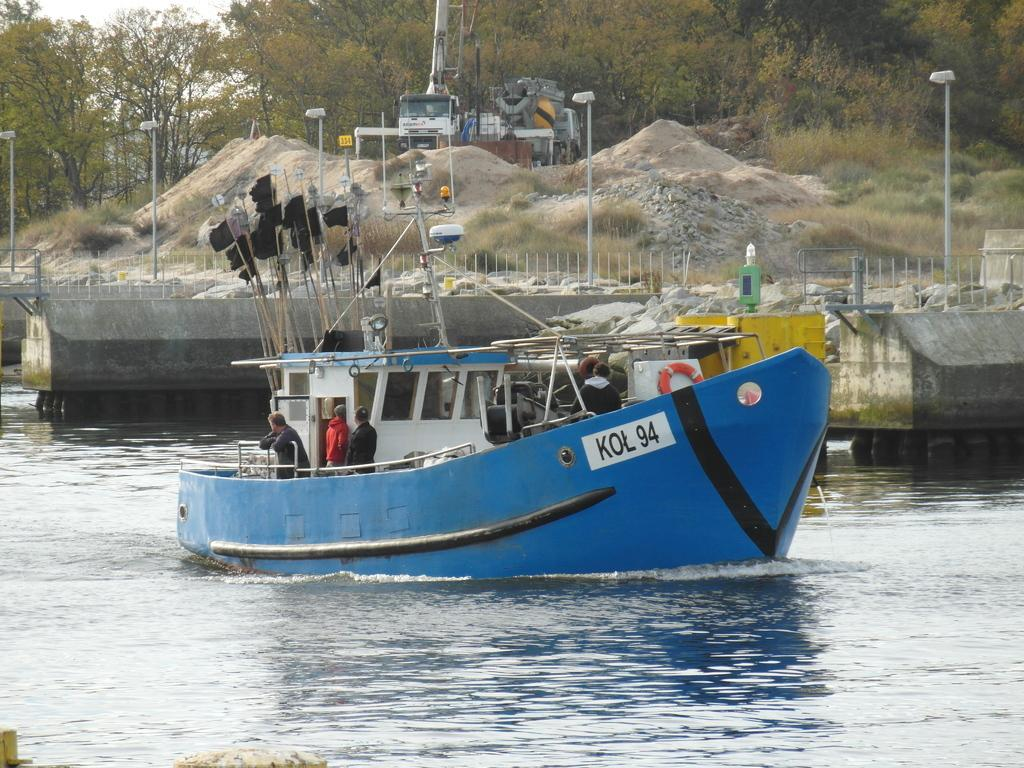What is the main subject in the foreground of the image? There is a boat in the foreground of the image. Where is the boat located? The boat is in the water. What can be seen in the background of the image? In the background, there is a railing, poles, trees, sand, rocks, and grass. How does the boat maintain its balance on the expansion in the image? There is no expansion present in the image, and the boat maintains its balance by floating on the water. What type of boot is being worn by the person in the image? There are no people visible in the image, and therefore no boots can be observed. 